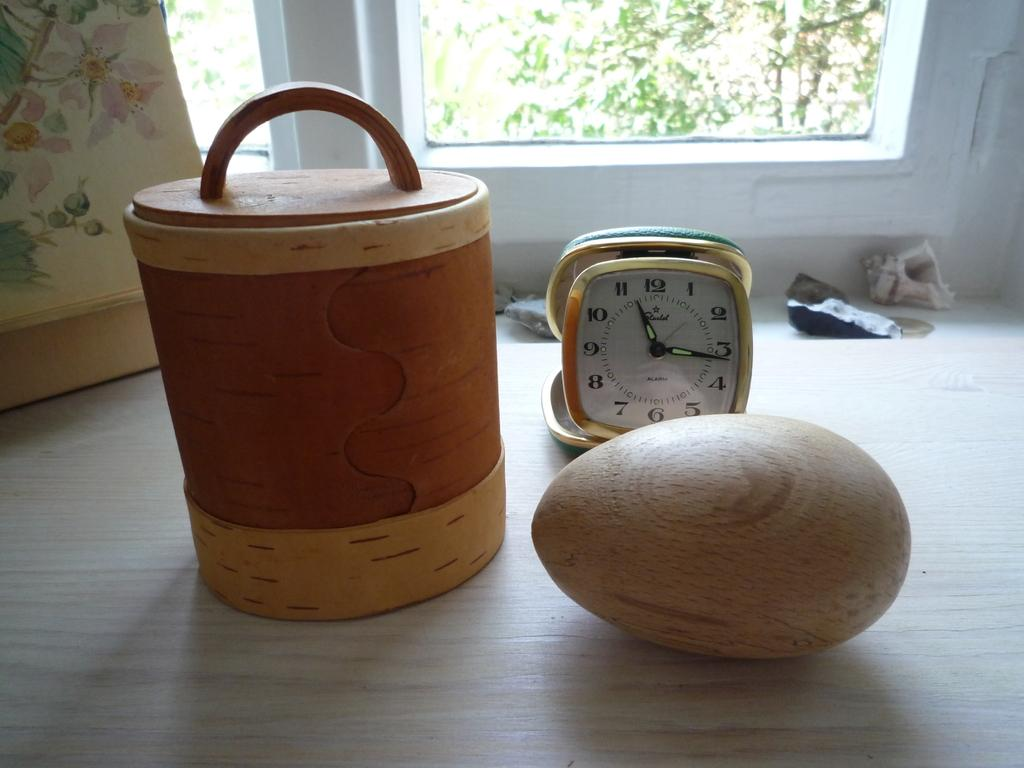<image>
Describe the image concisely. A container and a wood egg sit on a counter in front of clock that shows the time as 11:16. 